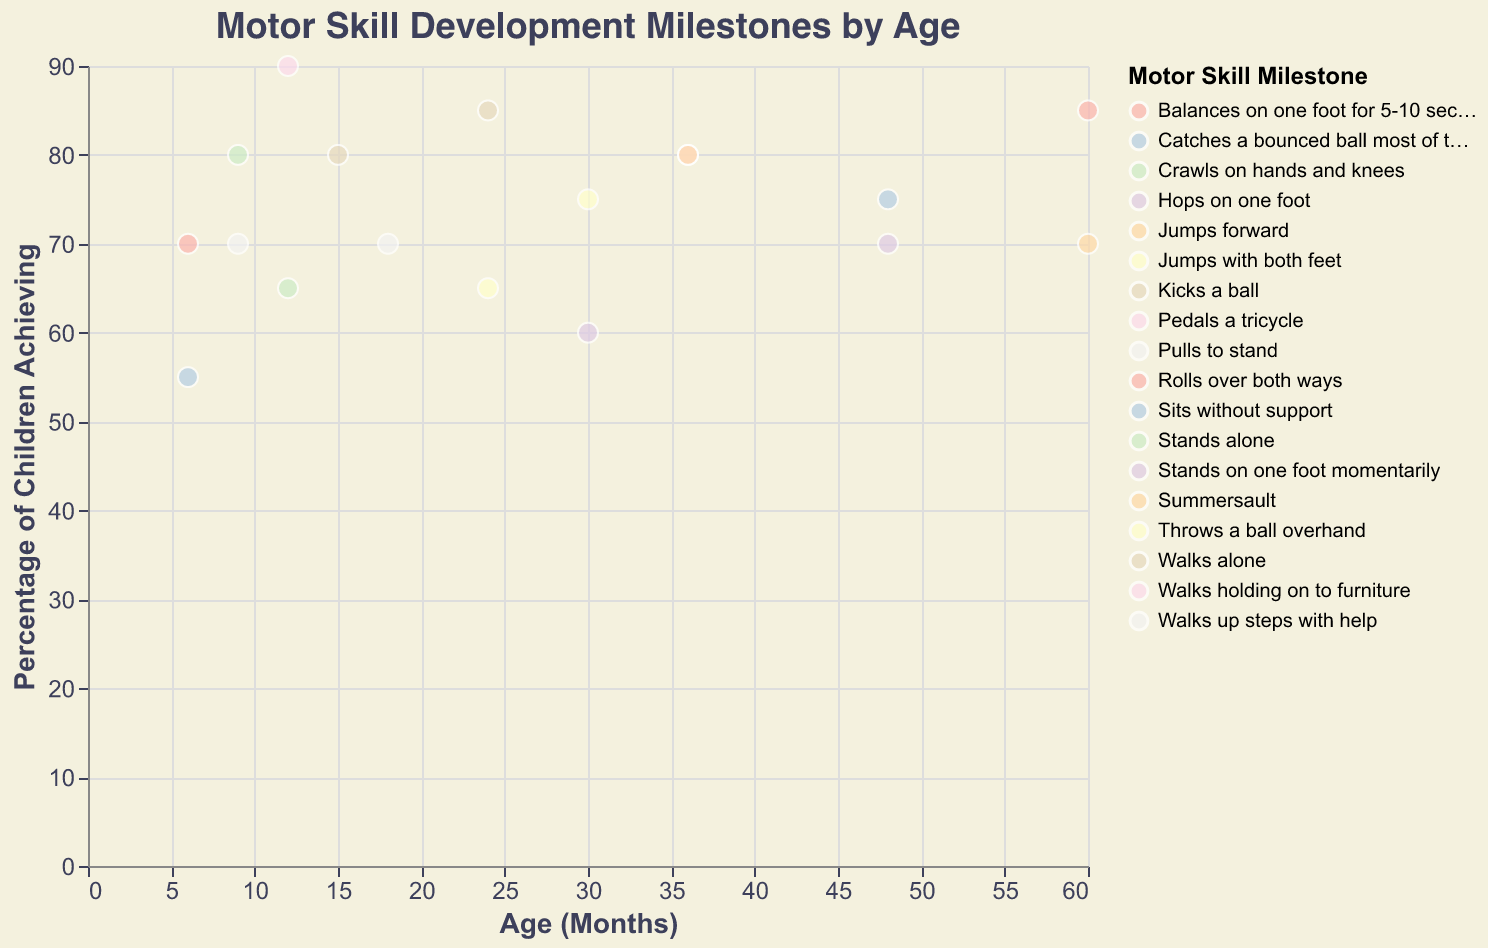What's the title of the figure? The title is displayed prominently above the scatter plot. It reads "Motor Skill Development Milestones by Age".
Answer: Motor Skill Development Milestones by Age What does the x-axis represent? The x-axis, labeled "Age (Months)", represents the age of children in months.
Answer: Age (Months) How many milestones are recorded at 24 months? By looking at the x-axis at 24 months and counting the data points, we see two milestones, "Jumps with both feet" and "Kicks a ball".
Answer: 2 Which age group has the highest percentage of children achieving a milestone? The age group with the highest percentage can be found by identifying the highest y-axis value. The highest percentage appears at 12 months for "Walks holding on to furniture" with 90%.
Answer: 12 months At what age do 85% of children achieve a milestone? By looking at the y-axis and observing the points that align with 85%, we find this happens at 24 months with "Kicks a ball" and 60 months with "Balances on one foot for 5-10 seconds".
Answer: 24 and 60 months Which motor skill has the lowest percentage of children achieving it, and what is the percentage? By scanning the y-axis for the lowest value, we find the milestone "Stands on one foot momentarily" at 30 months with 60% of children achieving it.
Answer: Stands on one foot momentarily, 60% How does the percentage of children achieving "Rolls over both ways" at 6 months compare to those who "Sits without support"? "Rolls over both ways" at 6 months is achieved by 70% of children, while "Sits without support" is achieved by 55%, so "Rolls over both ways" has a higher percentage.
Answer: Rolls over both ways has a higher percentage What is the average percentage of children achieving milestones at 36 months? At 36 months, there are two data points: "Pedals a tricycle" and "Jumps forward", both have 80%. Average = (80+80)/2 = 80%.
Answer: 80% Which milestone at 48 months has a higher percentage of achievement, "Hops on one foot" or "Catches a bounced ball most of the time"? At 48 months, "Catches a bounced ball most of the time" is achieved by 75% of children, while "Hops on one foot" is achieved by 70%.
Answer: Catches a bounced ball most of the time What milestones do children achieve by age 12 months with at least 65% success rate? At 12 months, the milestones "Walks holding on to furniture" (90%) and "Stands alone" (65%) are achieved by at least 65% of children.
Answer: Walks holding on to furniture, Stands alone 